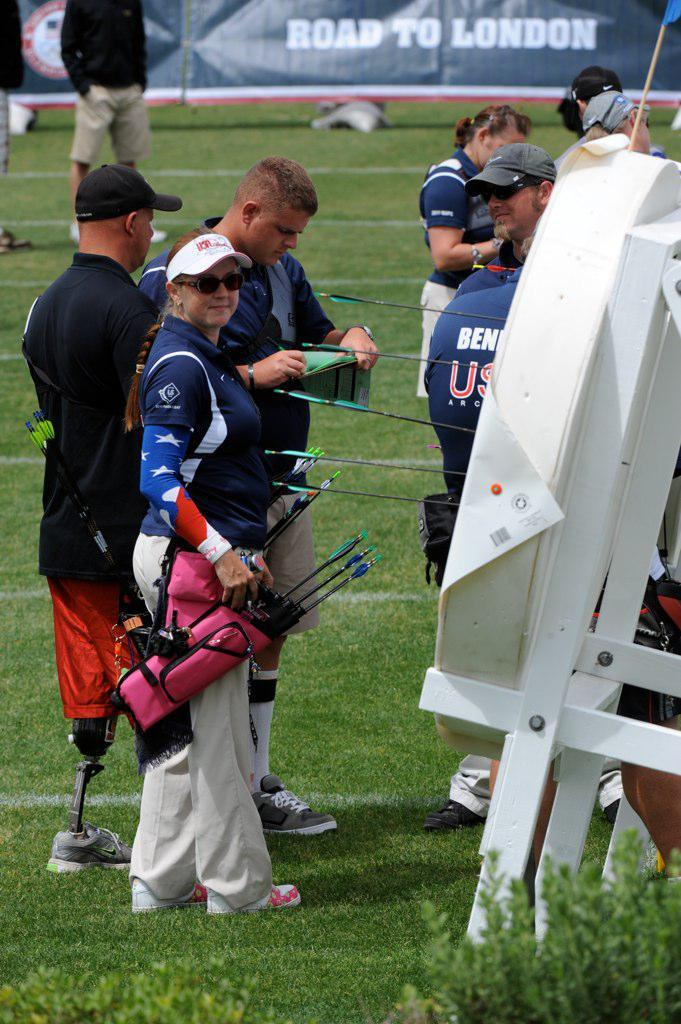<image>
Give a short and clear explanation of the subsequent image. road to london is advertised at the archery competition 